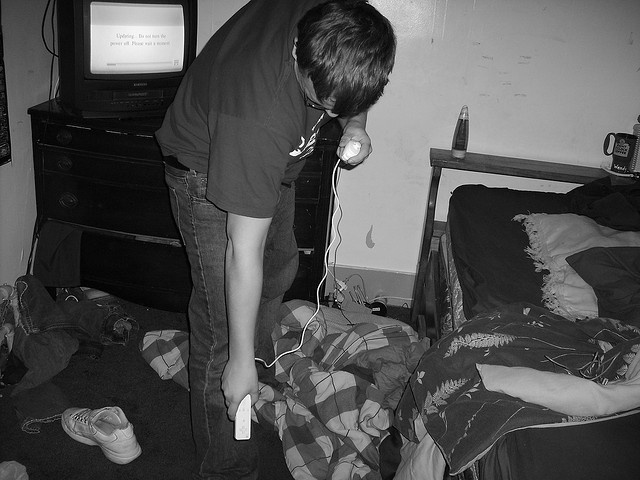Describe the objects in this image and their specific colors. I can see couch in black, gray, darkgray, and lightgray tones, people in black, gray, darkgray, and lightgray tones, bed in black, gray, and lightgray tones, tv in black, lightgray, darkgray, and gray tones, and cup in black, gray, darkgray, and lightgray tones in this image. 